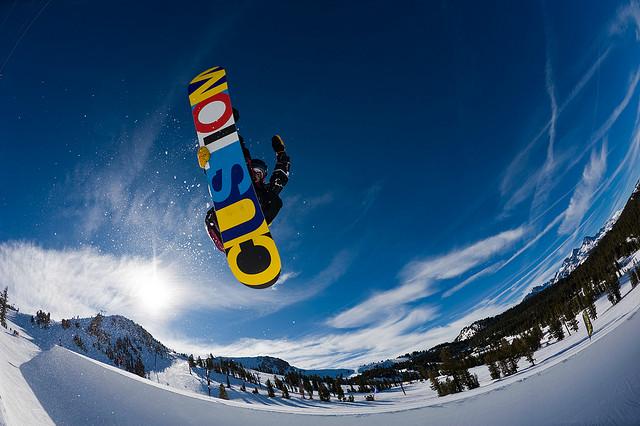Which hand is the man holding the snowboard with?
Be succinct. Right. What does the bottom of the snowboard say?
Quick response, please. Custom. What color is the person's gloves?
Give a very brief answer. Yellow. 